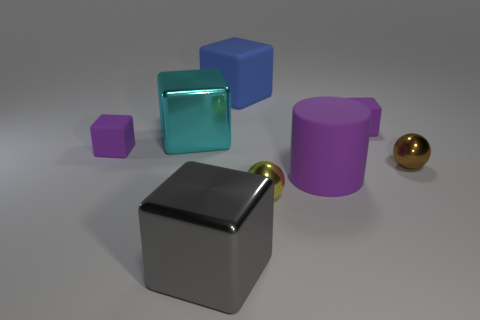What is the texture and color of the object furthest on the right? The object furthest on the right is a yellow sphere with what appears to be a smooth and shiny texture, suggesting it's made of a material like polished metal. 